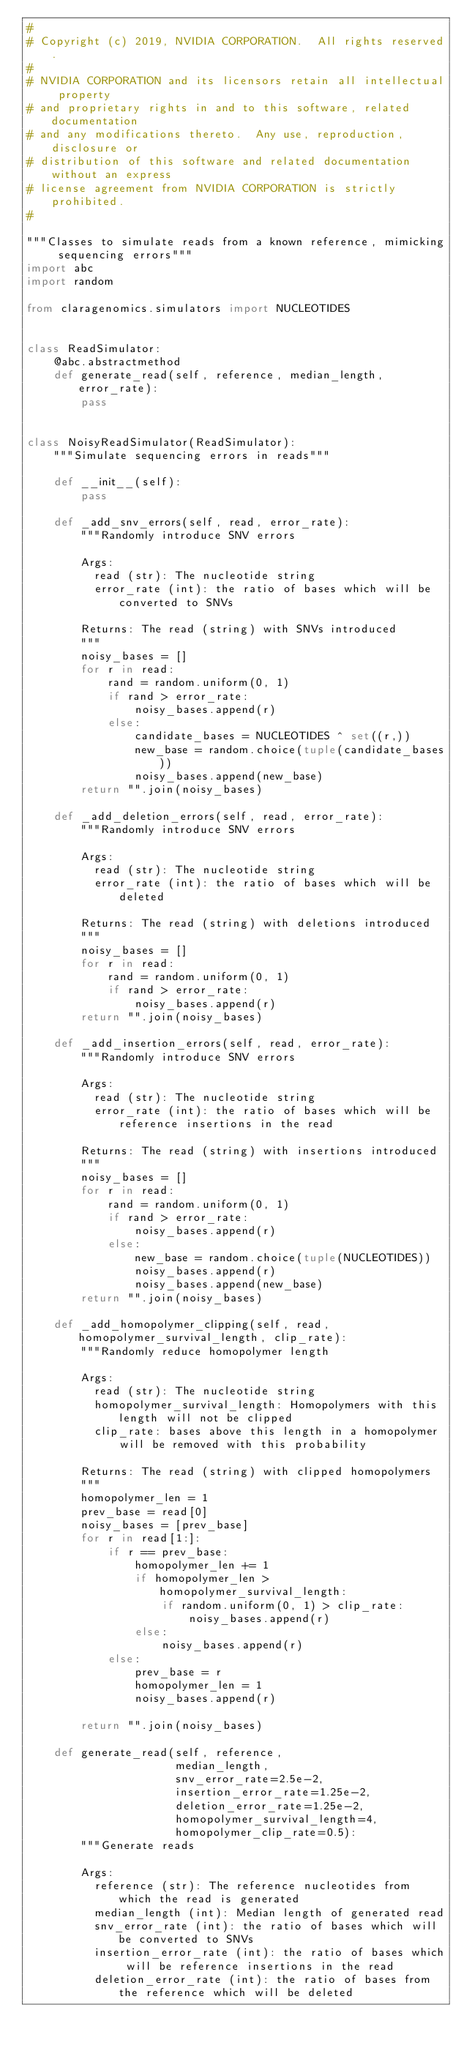Convert code to text. <code><loc_0><loc_0><loc_500><loc_500><_Python_>#
# Copyright (c) 2019, NVIDIA CORPORATION.  All rights reserved.
#
# NVIDIA CORPORATION and its licensors retain all intellectual property
# and proprietary rights in and to this software, related documentation
# and any modifications thereto.  Any use, reproduction, disclosure or
# distribution of this software and related documentation without an express
# license agreement from NVIDIA CORPORATION is strictly prohibited.
#

"""Classes to simulate reads from a known reference, mimicking sequencing errors"""
import abc
import random

from claragenomics.simulators import NUCLEOTIDES


class ReadSimulator:
    @abc.abstractmethod
    def generate_read(self, reference, median_length, error_rate):
        pass


class NoisyReadSimulator(ReadSimulator):
    """Simulate sequencing errors in reads"""

    def __init__(self):
        pass

    def _add_snv_errors(self, read, error_rate):
        """Randomly introduce SNV errors

        Args:
          read (str): The nucleotide string
          error_rate (int): the ratio of bases which will be converted to SNVs

        Returns: The read (string) with SNVs introduced
        """
        noisy_bases = []
        for r in read:
            rand = random.uniform(0, 1)
            if rand > error_rate:
                noisy_bases.append(r)
            else:
                candidate_bases = NUCLEOTIDES ^ set((r,))
                new_base = random.choice(tuple(candidate_bases))
                noisy_bases.append(new_base)
        return "".join(noisy_bases)

    def _add_deletion_errors(self, read, error_rate):
        """Randomly introduce SNV errors

        Args:
          read (str): The nucleotide string
          error_rate (int): the ratio of bases which will be deleted

        Returns: The read (string) with deletions introduced
        """
        noisy_bases = []
        for r in read:
            rand = random.uniform(0, 1)
            if rand > error_rate:
                noisy_bases.append(r)
        return "".join(noisy_bases)

    def _add_insertion_errors(self, read, error_rate):
        """Randomly introduce SNV errors

        Args:
          read (str): The nucleotide string
          error_rate (int): the ratio of bases which will be reference insertions in the read

        Returns: The read (string) with insertions introduced
        """
        noisy_bases = []
        for r in read:
            rand = random.uniform(0, 1)
            if rand > error_rate:
                noisy_bases.append(r)
            else:
                new_base = random.choice(tuple(NUCLEOTIDES))
                noisy_bases.append(r)
                noisy_bases.append(new_base)
        return "".join(noisy_bases)

    def _add_homopolymer_clipping(self, read, homopolymer_survival_length, clip_rate):
        """Randomly reduce homopolymer length

        Args:
          read (str): The nucleotide string
          homopolymer_survival_length: Homopolymers with this length will not be clipped
          clip_rate: bases above this length in a homopolymer will be removed with this probability

        Returns: The read (string) with clipped homopolymers
        """
        homopolymer_len = 1
        prev_base = read[0]
        noisy_bases = [prev_base]
        for r in read[1:]:
            if r == prev_base:
                homopolymer_len += 1
                if homopolymer_len > homopolymer_survival_length:
                    if random.uniform(0, 1) > clip_rate:
                        noisy_bases.append(r)
                else:
                    noisy_bases.append(r)
            else:
                prev_base = r
                homopolymer_len = 1
                noisy_bases.append(r)

        return "".join(noisy_bases)

    def generate_read(self, reference,
                      median_length,
                      snv_error_rate=2.5e-2,
                      insertion_error_rate=1.25e-2,
                      deletion_error_rate=1.25e-2,
                      homopolymer_survival_length=4,
                      homopolymer_clip_rate=0.5):
        """Generate reads

        Args:
          reference (str): The reference nucleotides from which the read is generated
          median_length (int): Median length of generated read
          snv_error_rate (int): the ratio of bases which will be converted to SNVs
          insertion_error_rate (int): the ratio of bases which will be reference insertions in the read
          deletion_error_rate (int): the ratio of bases from the reference which will be deleted</code> 